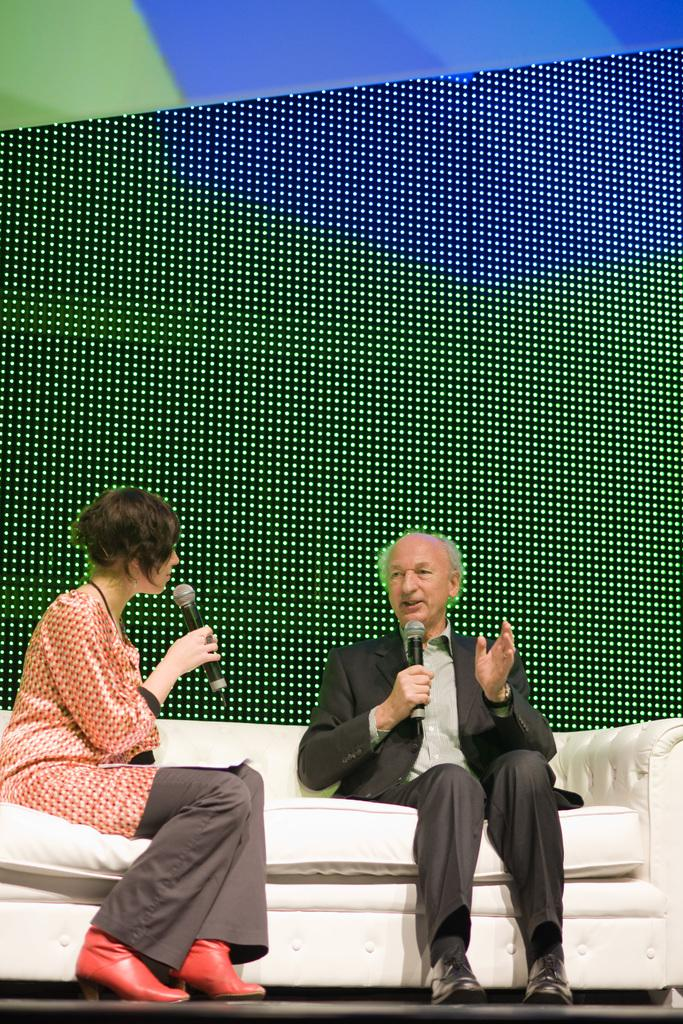How many people are sitting on the couch in the image? There are two people sitting on the couch in the image. What can be seen in addition to the couch and people? There is a digital screen in the image. What is the man doing in the image? A man is speaking into a microphone in the image. What is the level of disgust expressed by the people in the image? There is no indication of disgust in the image; the people are simply sitting on the couch. 